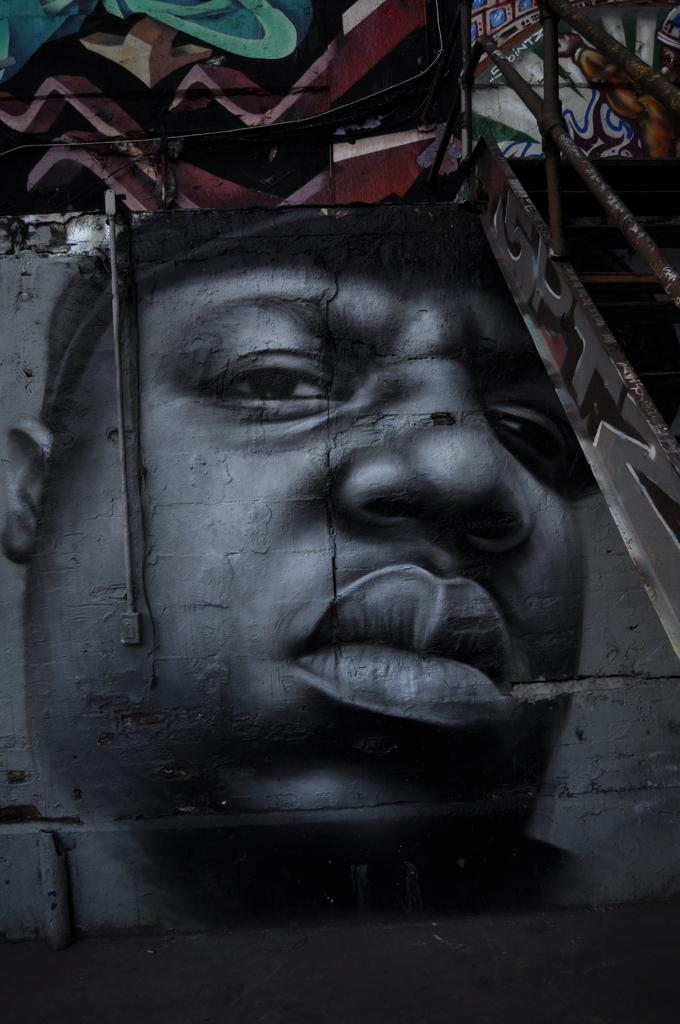What is the main subject of the image? The main subject of the image is an edited image of a man. What can be seen on the right side of the image? There is an iron fence on the right side of the image. What type of tomatoes can be seen in the image? There are no tomatoes present in the image. How many people are involved in the meal depicted in the image? The image does not depict a meal, so it cannot be determined how many people are involved. 